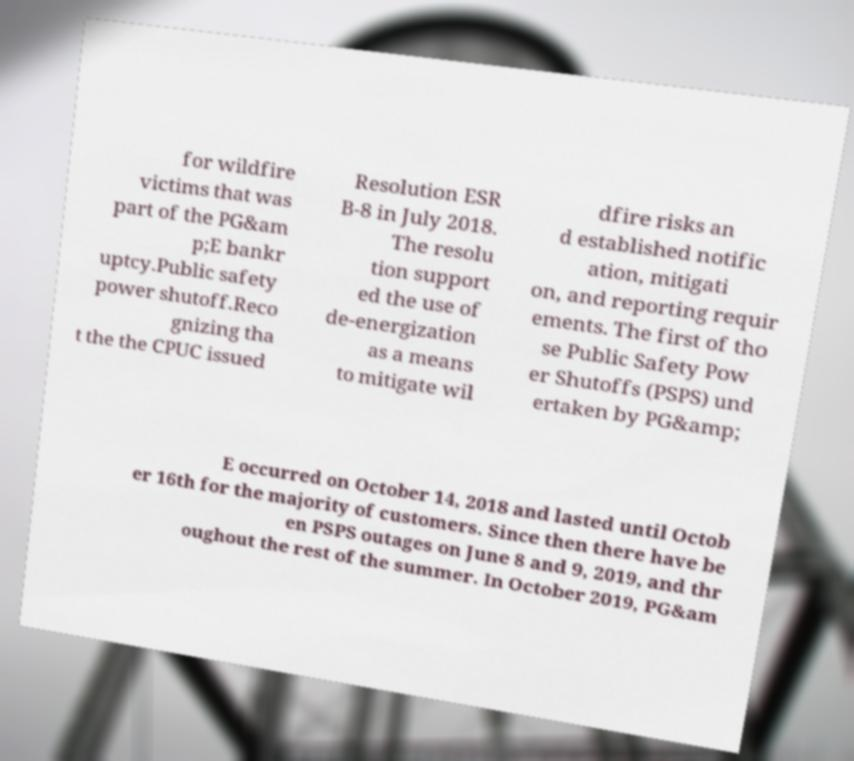There's text embedded in this image that I need extracted. Can you transcribe it verbatim? for wildfire victims that was part of the PG&am p;E bankr uptcy.Public safety power shutoff.Reco gnizing tha t the the CPUC issued Resolution ESR B-8 in July 2018. The resolu tion support ed the use of de-energization as a means to mitigate wil dfire risks an d established notific ation, mitigati on, and reporting requir ements. The first of tho se Public Safety Pow er Shutoffs (PSPS) und ertaken by PG&amp; E occurred on October 14, 2018 and lasted until Octob er 16th for the majority of customers. Since then there have be en PSPS outages on June 8 and 9, 2019, and thr oughout the rest of the summer. In October 2019, PG&am 